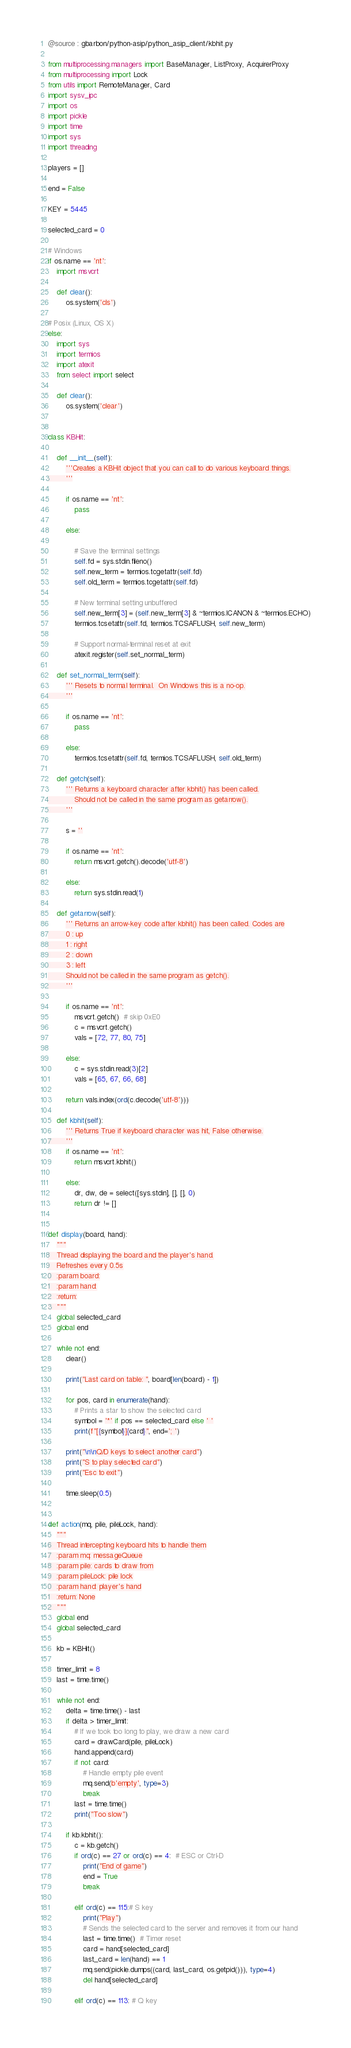<code> <loc_0><loc_0><loc_500><loc_500><_Python_>@source : gbarbon/python-asip/python_asip_client/kbhit.py 

from multiprocessing.managers import BaseManager, ListProxy, AcquirerProxy
from multiprocessing import Lock
from utils import RemoteManager, Card
import sysv_ipc
import os
import pickle
import time
import sys
import threading

players = []

end = False

KEY = 5445

selected_card = 0

# Windows
if os.name == 'nt':
    import msvcrt

    def clear():
        os.system('cls')

# Posix (Linux, OS X)
else:
    import sys
    import termios
    import atexit
    from select import select

    def clear():
        os.system('clear')


class KBHit:

    def __init__(self):
        '''Creates a KBHit object that you can call to do various keyboard things.
        '''

        if os.name == 'nt':
            pass

        else:

            # Save the terminal settings
            self.fd = sys.stdin.fileno()
            self.new_term = termios.tcgetattr(self.fd)
            self.old_term = termios.tcgetattr(self.fd)

            # New terminal setting unbuffered
            self.new_term[3] = (self.new_term[3] & ~termios.ICANON & ~termios.ECHO)
            termios.tcsetattr(self.fd, termios.TCSAFLUSH, self.new_term)

            # Support normal-terminal reset at exit
            atexit.register(self.set_normal_term)

    def set_normal_term(self):
        ''' Resets to normal terminal.  On Windows this is a no-op.
        '''

        if os.name == 'nt':
            pass

        else:
            termios.tcsetattr(self.fd, termios.TCSAFLUSH, self.old_term)

    def getch(self):
        ''' Returns a keyboard character after kbhit() has been called.
            Should not be called in the same program as getarrow().
        '''

        s = ''

        if os.name == 'nt':
            return msvcrt.getch().decode('utf-8')

        else:
            return sys.stdin.read(1)

    def getarrow(self):
        ''' Returns an arrow-key code after kbhit() has been called. Codes are
        0 : up
        1 : right
        2 : down
        3 : left
        Should not be called in the same program as getch().
        '''

        if os.name == 'nt':
            msvcrt.getch()  # skip 0xE0
            c = msvcrt.getch()
            vals = [72, 77, 80, 75]

        else:
            c = sys.stdin.read(3)[2]
            vals = [65, 67, 66, 68]

        return vals.index(ord(c.decode('utf-8')))

    def kbhit(self):
        ''' Returns True if keyboard character was hit, False otherwise.
        '''
        if os.name == 'nt':
            return msvcrt.kbhit()

        else:
            dr, dw, de = select([sys.stdin], [], [], 0)
            return dr != []


def display(board, hand):
    """
    Thread displaying the board and the player's hand.
    Refreshes every 0.5s
    :param board:
    :param hand:
    :return:
    """
    global selected_card
    global end

    while not end:
        clear()

        print("Last card on table: ", board[len(board) - 1])

        for pos, card in enumerate(hand):
            # Prints a star to show the selected card
            symbol = '*' if pos == selected_card else ' '
            print(f"[{symbol}]{card}", end='; ')

        print("\n\nQ/D keys to select another card")
        print("S to play selected card")
        print("Esc to exit")

        time.sleep(0.5)


def action(mq, pile, pileLock, hand):
    """
    Thread intercepting keyboard hits to handle them
    :param mq: messageQueue
    :param pile: cards to draw from
    :param pileLock: pile lock
    :param hand: player's hand
    :return: None
    """
    global end
    global selected_card

    kb = KBHit()

    timer_limit = 8
    last = time.time()

    while not end:
        delta = time.time() - last
        if delta > timer_limit:
            # If we took too long to play, we draw a new card
            card = drawCard(pile, pileLock)
            hand.append(card)
            if not card:
                # Handle empty pile event
                mq.send(b'empty', type=3)
                break
            last = time.time()
            print("Too slow")

        if kb.kbhit():
            c = kb.getch()
            if ord(c) == 27 or ord(c) == 4:  # ESC or Ctrl-D
                print("End of game")
                end = True
                break

            elif ord(c) == 115:# S key
                print("Play")
                # Sends the selected card to the server and removes it from our hand
                last = time.time()  # Timer reset
                card = hand[selected_card]
                last_card = len(hand) == 1
                mq.send(pickle.dumps((card, last_card, os.getpid())), type=4)
                del hand[selected_card]

            elif ord(c) == 113: # Q key</code> 